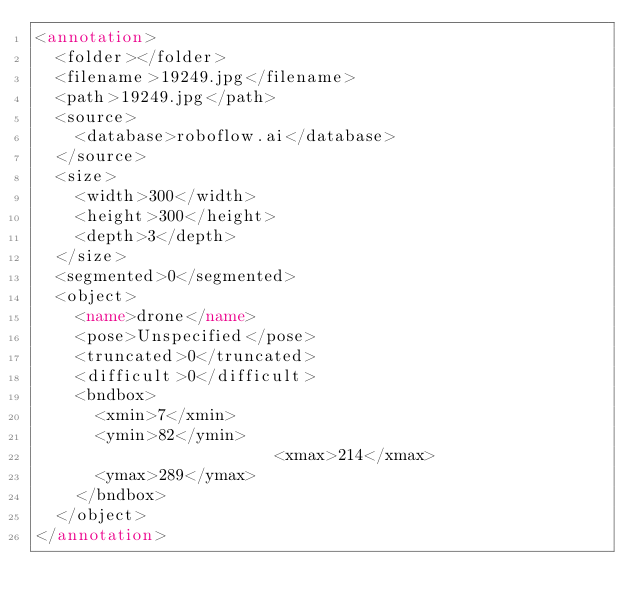Convert code to text. <code><loc_0><loc_0><loc_500><loc_500><_XML_><annotation>
	<folder></folder>
	<filename>19249.jpg</filename>
	<path>19249.jpg</path>
	<source>
		<database>roboflow.ai</database>
	</source>
	<size>
		<width>300</width>
		<height>300</height>
		<depth>3</depth>
	</size>
	<segmented>0</segmented>
	<object>
		<name>drone</name>
		<pose>Unspecified</pose>
		<truncated>0</truncated>
		<difficult>0</difficult>
		<bndbox>
			<xmin>7</xmin>
			<ymin>82</ymin>
                        <xmax>214</xmax>
			<ymax>289</ymax>
		</bndbox>
	</object>
</annotation>
</code> 